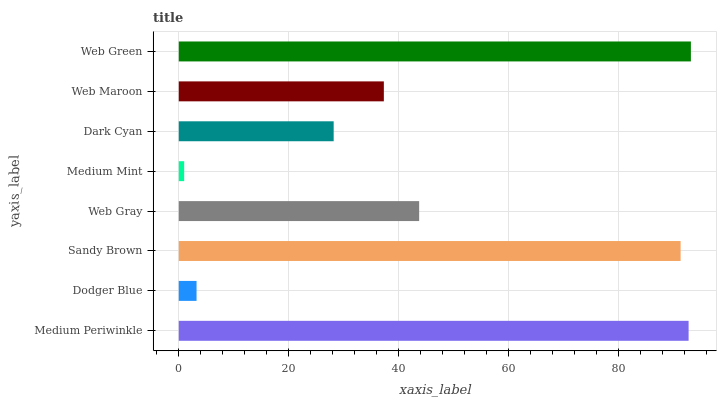Is Medium Mint the minimum?
Answer yes or no. Yes. Is Web Green the maximum?
Answer yes or no. Yes. Is Dodger Blue the minimum?
Answer yes or no. No. Is Dodger Blue the maximum?
Answer yes or no. No. Is Medium Periwinkle greater than Dodger Blue?
Answer yes or no. Yes. Is Dodger Blue less than Medium Periwinkle?
Answer yes or no. Yes. Is Dodger Blue greater than Medium Periwinkle?
Answer yes or no. No. Is Medium Periwinkle less than Dodger Blue?
Answer yes or no. No. Is Web Gray the high median?
Answer yes or no. Yes. Is Web Maroon the low median?
Answer yes or no. Yes. Is Medium Mint the high median?
Answer yes or no. No. Is Medium Mint the low median?
Answer yes or no. No. 